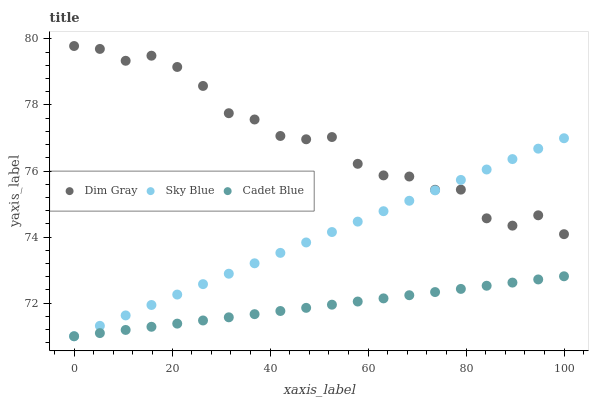Does Cadet Blue have the minimum area under the curve?
Answer yes or no. Yes. Does Dim Gray have the maximum area under the curve?
Answer yes or no. Yes. Does Sky Blue have the minimum area under the curve?
Answer yes or no. No. Does Sky Blue have the maximum area under the curve?
Answer yes or no. No. Is Sky Blue the smoothest?
Answer yes or no. Yes. Is Dim Gray the roughest?
Answer yes or no. Yes. Is Dim Gray the smoothest?
Answer yes or no. No. Is Sky Blue the roughest?
Answer yes or no. No. Does Cadet Blue have the lowest value?
Answer yes or no. Yes. Does Dim Gray have the lowest value?
Answer yes or no. No. Does Dim Gray have the highest value?
Answer yes or no. Yes. Does Sky Blue have the highest value?
Answer yes or no. No. Is Cadet Blue less than Dim Gray?
Answer yes or no. Yes. Is Dim Gray greater than Cadet Blue?
Answer yes or no. Yes. Does Cadet Blue intersect Sky Blue?
Answer yes or no. Yes. Is Cadet Blue less than Sky Blue?
Answer yes or no. No. Is Cadet Blue greater than Sky Blue?
Answer yes or no. No. Does Cadet Blue intersect Dim Gray?
Answer yes or no. No. 